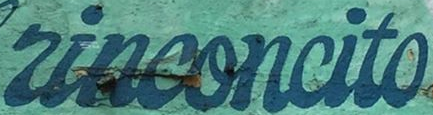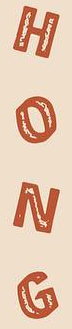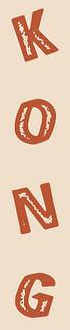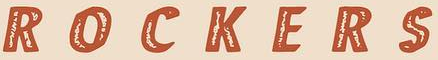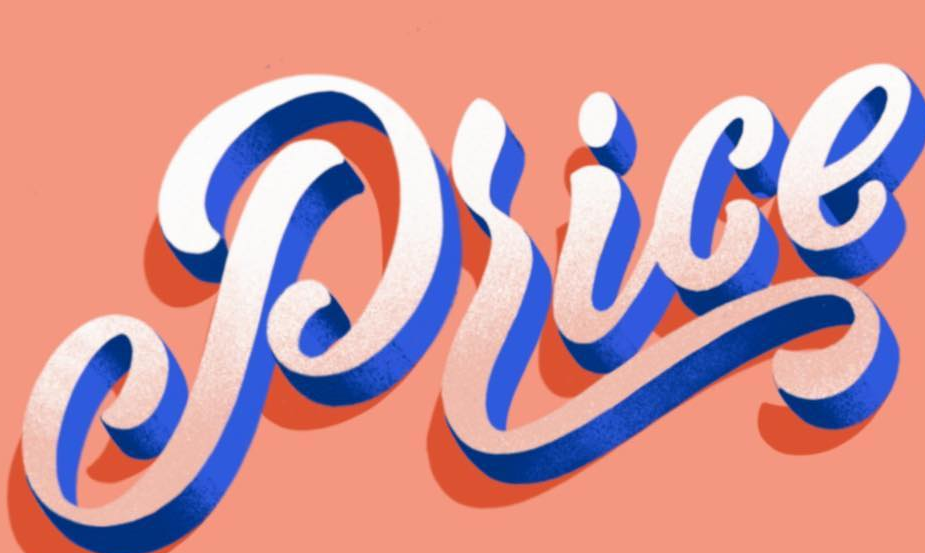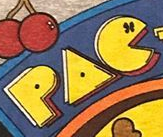What words are shown in these images in order, separated by a semicolon? rinconcito; HONG; KONG; ROCKERS; Price; PAC 